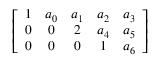Convert formula to latex. <formula><loc_0><loc_0><loc_500><loc_500>\left [ { \begin{array} { c c c c c } { 1 } & { a _ { 0 } } & { a _ { 1 } } & { a _ { 2 } } & { a _ { 3 } } \\ { 0 } & { 0 } & { 2 } & { a _ { 4 } } & { a _ { 5 } } \\ { 0 } & { 0 } & { 0 } & { 1 } & { a _ { 6 } } \end{array} } \right ]</formula> 